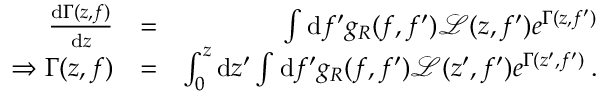Convert formula to latex. <formula><loc_0><loc_0><loc_500><loc_500>\begin{array} { r l r } { \frac { d \Gamma ( z , f ) } { d z } } & { = } & { \int d f ^ { \prime } g _ { R } ( f , f ^ { \prime } ) \mathcal { L } ( z , f ^ { \prime } ) e ^ { \Gamma ( z , f ^ { \prime } ) } } \\ { \Rightarrow \Gamma ( z , f ) } & { = } & { \int _ { 0 } ^ { z } d z ^ { \prime } \int d f ^ { \prime } g _ { R } ( f , f ^ { \prime } ) \mathcal { L } ( z ^ { \prime } , f ^ { \prime } ) e ^ { \Gamma ( z ^ { \prime } , f ^ { \prime } ) } \, . } \end{array}</formula> 